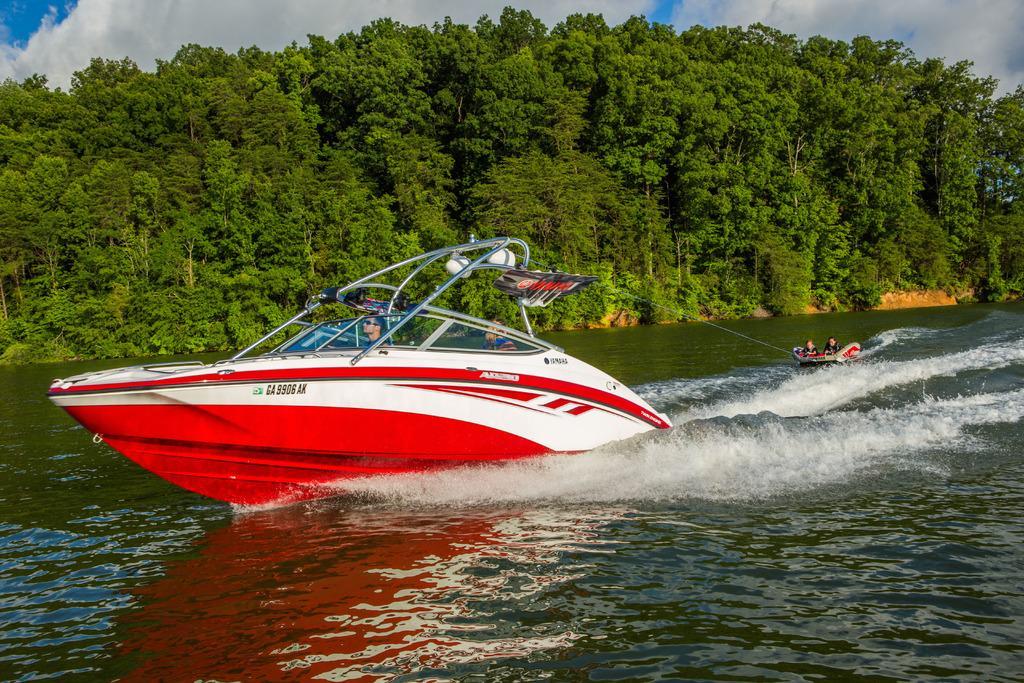How would you summarize this image in a sentence or two? In the foreground of this image, there is a boat and also a raft tied to it which is moving on the water. In the background, there are trees, sky and the cloud. 